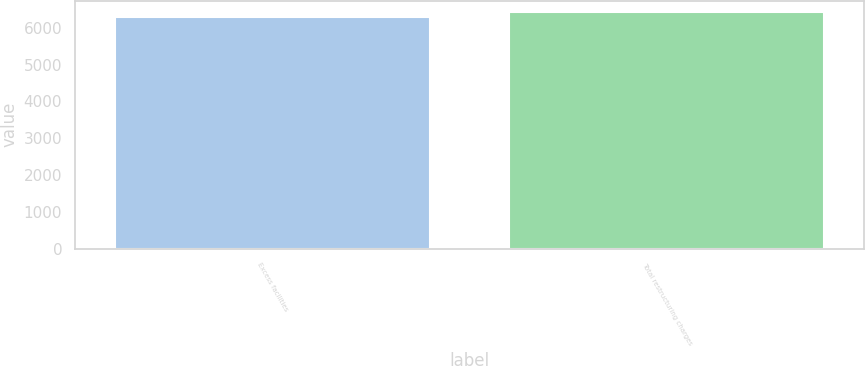Convert chart. <chart><loc_0><loc_0><loc_500><loc_500><bar_chart><fcel>Excess facilities<fcel>Total restructuring charges<nl><fcel>6300<fcel>6421<nl></chart> 